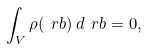<formula> <loc_0><loc_0><loc_500><loc_500>\int _ { V } \rho ( \ r b ) \, d \ r b = 0 ,</formula> 